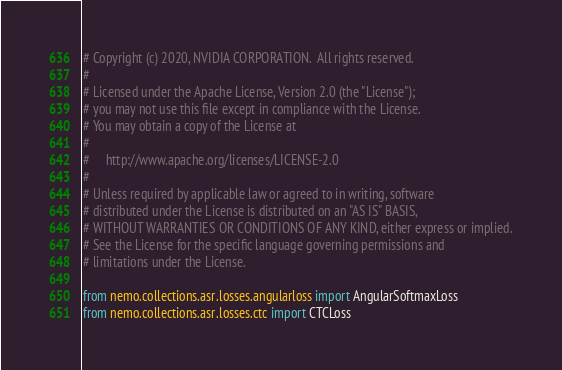<code> <loc_0><loc_0><loc_500><loc_500><_Python_># Copyright (c) 2020, NVIDIA CORPORATION.  All rights reserved.
#
# Licensed under the Apache License, Version 2.0 (the "License");
# you may not use this file except in compliance with the License.
# You may obtain a copy of the License at
#
#     http://www.apache.org/licenses/LICENSE-2.0
#
# Unless required by applicable law or agreed to in writing, software
# distributed under the License is distributed on an "AS IS" BASIS,
# WITHOUT WARRANTIES OR CONDITIONS OF ANY KIND, either express or implied.
# See the License for the specific language governing permissions and
# limitations under the License.

from nemo.collections.asr.losses.angularloss import AngularSoftmaxLoss
from nemo.collections.asr.losses.ctc import CTCLoss
</code> 